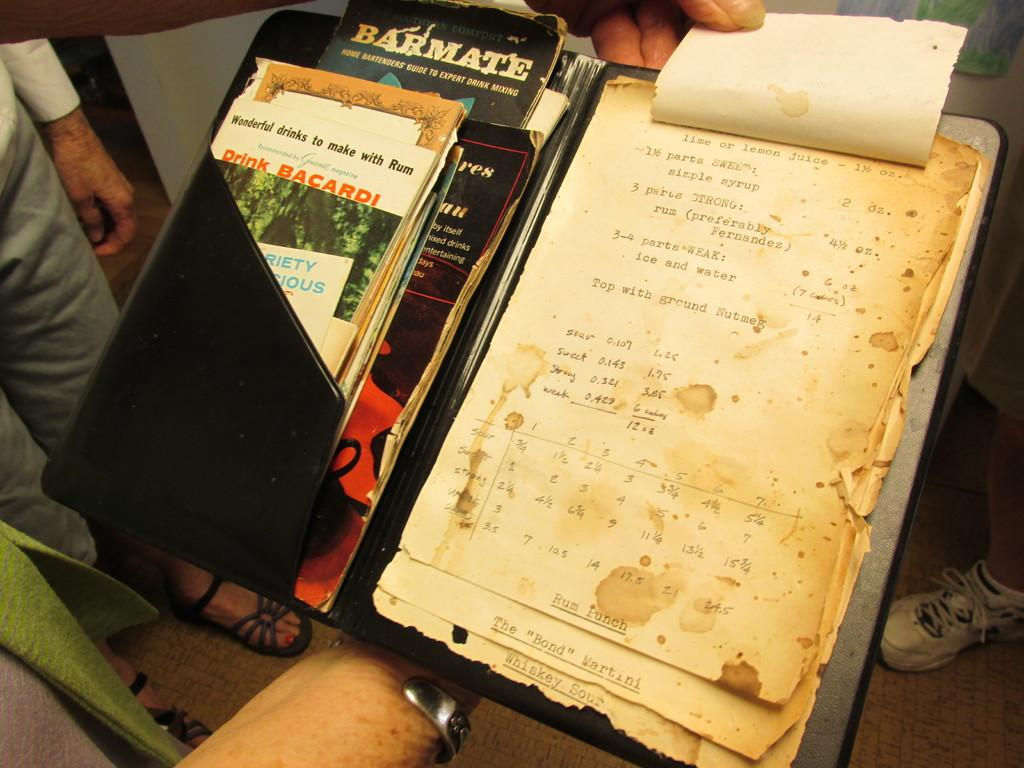<image>
Render a clear and concise summary of the photo. An old recipe book for cocktails with "lime or lemon juice" as an ingredient 